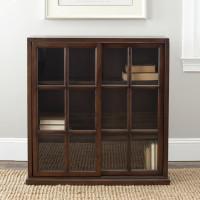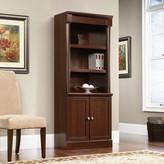The first image is the image on the left, the second image is the image on the right. Considering the images on both sides, is "There is 1 ivory colored chair next to a tall bookcase." valid? Answer yes or no. Yes. 